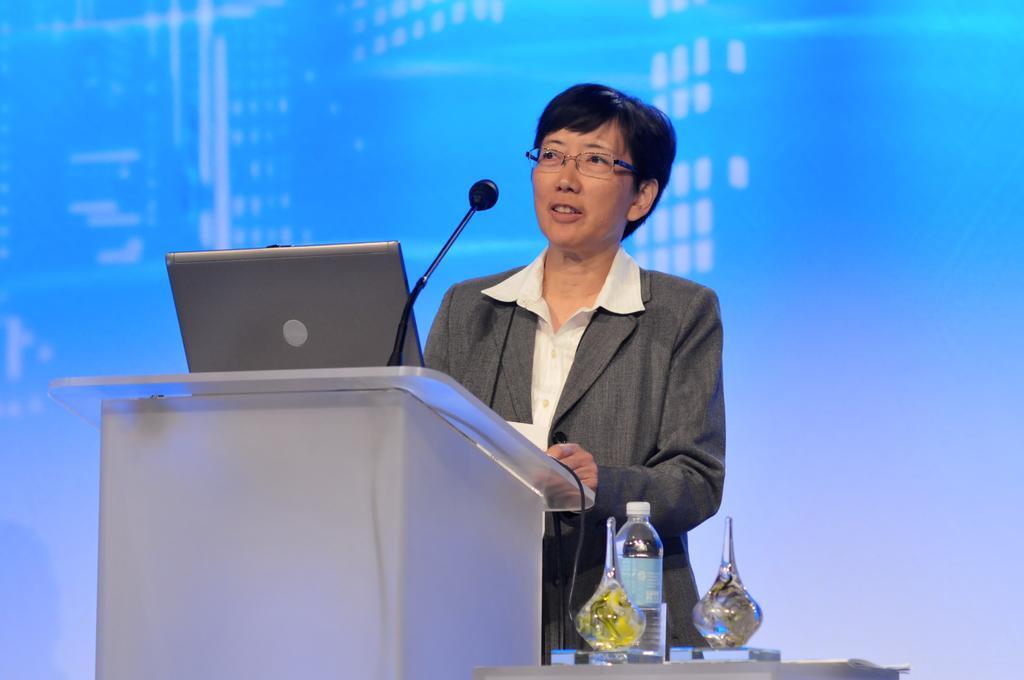Describe this image in one or two sentences. In this image there is a person who is standing in front of podium and speaking through the mic. There is also laptop on the podium. Beside the man there is a table on which there is bottle,flower vase. 